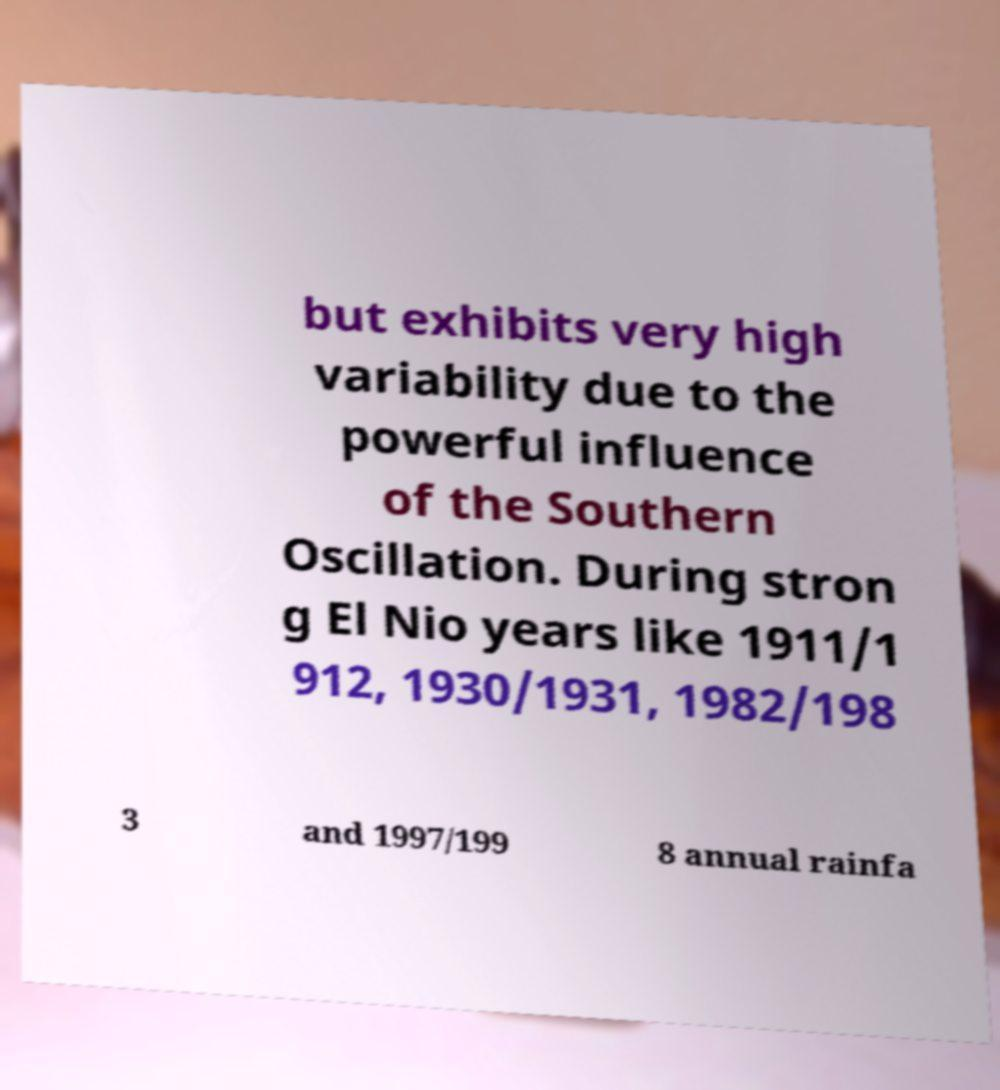Can you accurately transcribe the text from the provided image for me? but exhibits very high variability due to the powerful influence of the Southern Oscillation. During stron g El Nio years like 1911/1 912, 1930/1931, 1982/198 3 and 1997/199 8 annual rainfa 